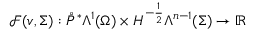<formula> <loc_0><loc_0><loc_500><loc_500>\mathcal { F } ( v , \Sigma ) \colon \mathring { P } ^ { \ast } \Lambda ^ { 1 } ( \Omega ) \times H ^ { - \frac { 1 } { 2 } } \Lambda ^ { n - 1 } ( \Sigma ) \to \mathbb { R }</formula> 